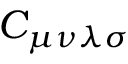Convert formula to latex. <formula><loc_0><loc_0><loc_500><loc_500>C _ { \mu \nu \lambda \sigma }</formula> 